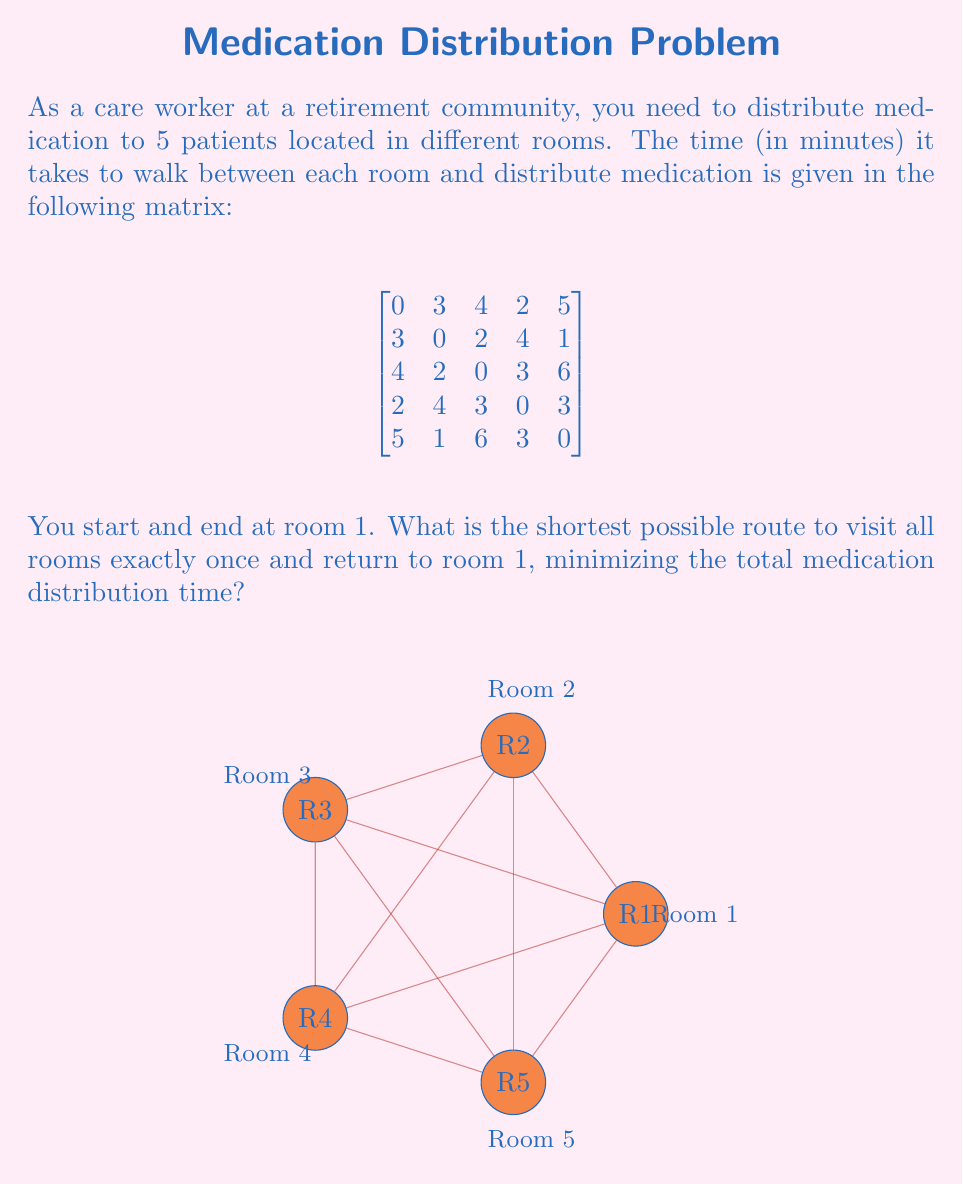Help me with this question. This problem is an instance of the Traveling Salesman Problem (TSP). To solve it, we'll use the following steps:

1) List all possible routes:
   There are $(5-1)! = 24$ possible routes, as we start and end at room 1.

2) Calculate the total time for each route:
   For example, route 1-2-3-4-5-1:
   Time = 3 + 2 + 3 + 3 + 5 = 16 minutes

3) Compare all routes to find the minimum:
   After calculating all 24 routes, we find that the shortest route is:

   1-4-3-2-5-1

4) Calculate the total time for this route:
   1 to 4: 2 minutes
   4 to 3: 3 minutes
   3 to 2: 2 minutes
   2 to 5: 1 minute
   5 to 1: 5 minutes

   Total time = 2 + 3 + 2 + 1 + 5 = 13 minutes

This route minimizes the total medication distribution time while visiting all rooms exactly once and returning to the starting point.
Answer: 13 minutes 